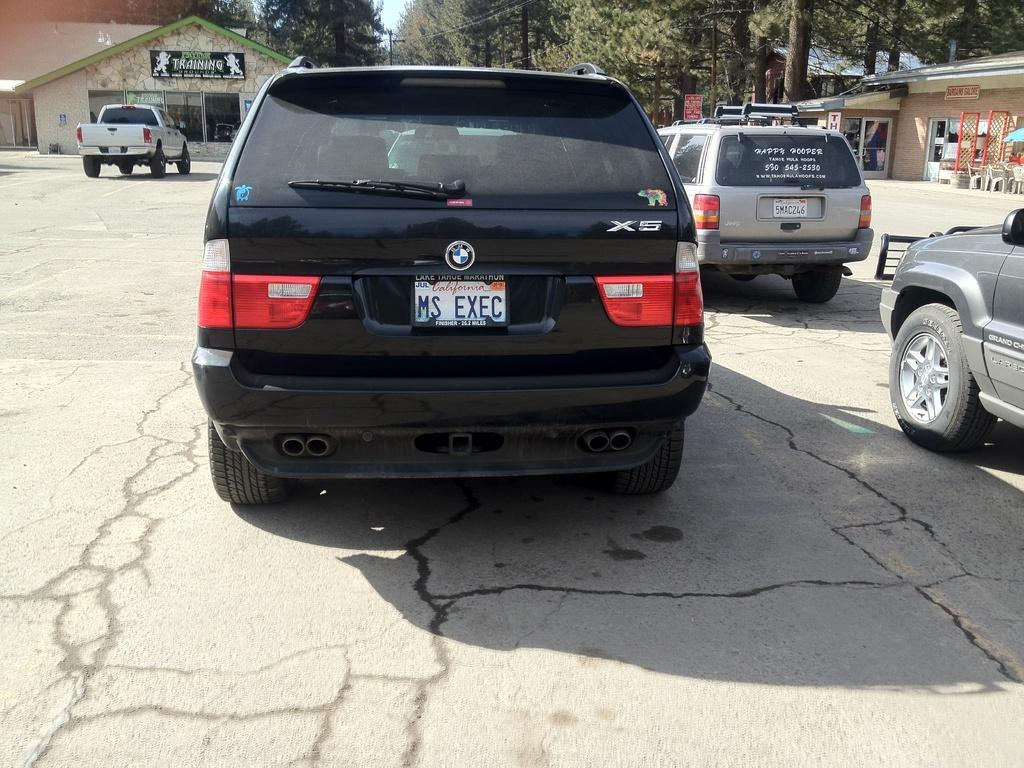<image>
Offer a succinct explanation of the picture presented. A black car's license plate reads MS EXEC. 